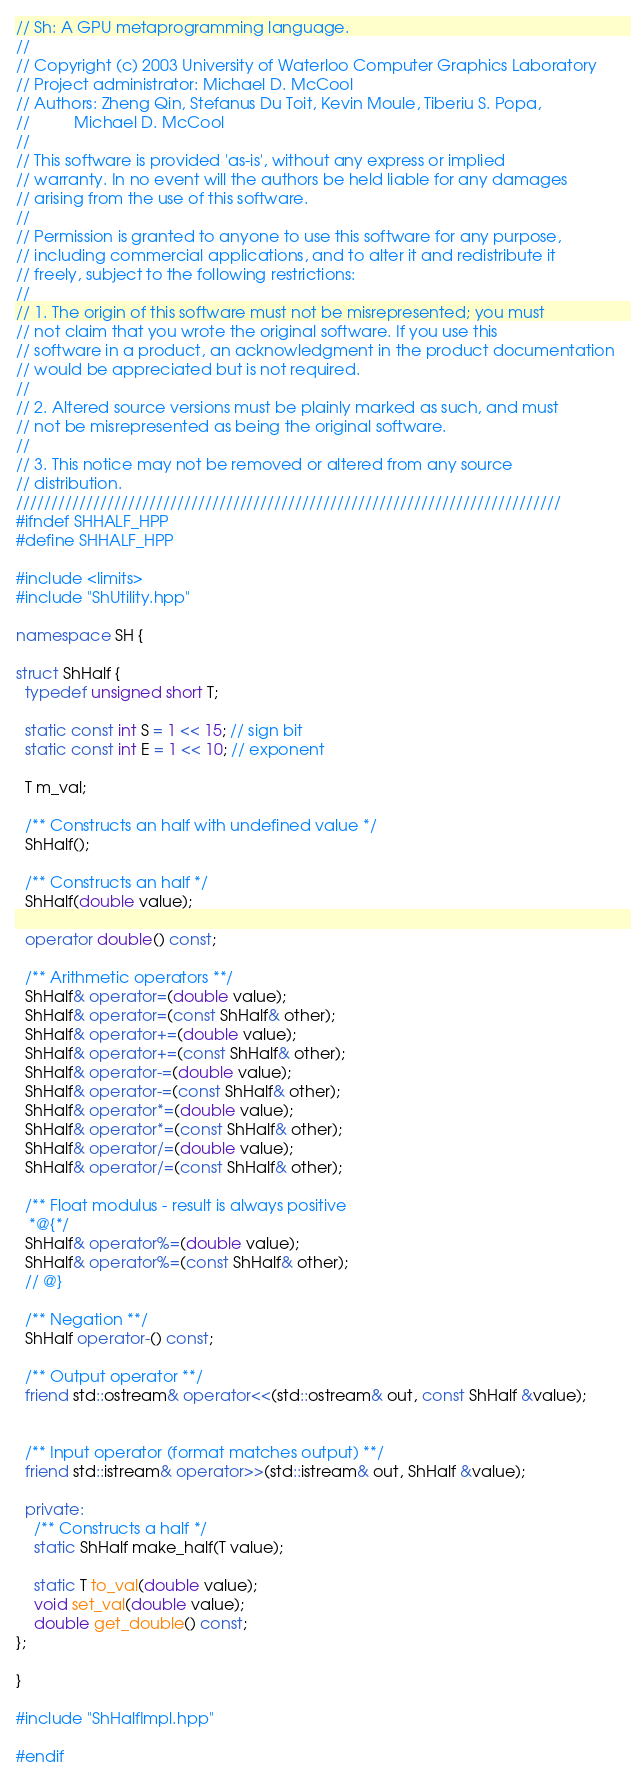Convert code to text. <code><loc_0><loc_0><loc_500><loc_500><_C++_>// Sh: A GPU metaprogramming language.
//
// Copyright (c) 2003 University of Waterloo Computer Graphics Laboratory
// Project administrator: Michael D. McCool
// Authors: Zheng Qin, Stefanus Du Toit, Kevin Moule, Tiberiu S. Popa,
//          Michael D. McCool
// 
// This software is provided 'as-is', without any express or implied
// warranty. In no event will the authors be held liable for any damages
// arising from the use of this software.
// 
// Permission is granted to anyone to use this software for any purpose,
// including commercial applications, and to alter it and redistribute it
// freely, subject to the following restrictions:
// 
// 1. The origin of this software must not be misrepresented; you must
// not claim that you wrote the original software. If you use this
// software in a product, an acknowledgment in the product documentation
// would be appreciated but is not required.
// 
// 2. Altered source versions must be plainly marked as such, and must
// not be misrepresented as being the original software.
// 
// 3. This notice may not be removed or altered from any source
// distribution.
//////////////////////////////////////////////////////////////////////////////
#ifndef SHHALF_HPP
#define SHHALF_HPP

#include <limits>
#include "ShUtility.hpp"

namespace SH {

struct ShHalf {
  typedef unsigned short T; 

  static const int S = 1 << 15; // sign bit
  static const int E = 1 << 10; // exponent 

  T m_val;

  /** Constructs an half with undefined value */
  ShHalf();

  /** Constructs an half */
  ShHalf(double value); 

  operator double() const;

  /** Arithmetic operators **/
  ShHalf& operator=(double value);
  ShHalf& operator=(const ShHalf& other);
  ShHalf& operator+=(double value);
  ShHalf& operator+=(const ShHalf& other);
  ShHalf& operator-=(double value);
  ShHalf& operator-=(const ShHalf& other);
  ShHalf& operator*=(double value);
  ShHalf& operator*=(const ShHalf& other);
  ShHalf& operator/=(double value);
  ShHalf& operator/=(const ShHalf& other);

  /** Float modulus - result is always positive 
   *@{*/
  ShHalf& operator%=(double value);
  ShHalf& operator%=(const ShHalf& other);
  // @}

  /** Negation **/
  ShHalf operator-() const;

  /** Output operator **/
  friend std::ostream& operator<<(std::ostream& out, const ShHalf &value);


  /** Input operator (format matches output) **/
  friend std::istream& operator>>(std::istream& out, ShHalf &value);

  private:
    /** Constructs a half */
    static ShHalf make_half(T value);

    static T to_val(double value);
    void set_val(double value);
    double get_double() const;
};

}

#include "ShHalfImpl.hpp"
  
#endif
</code> 